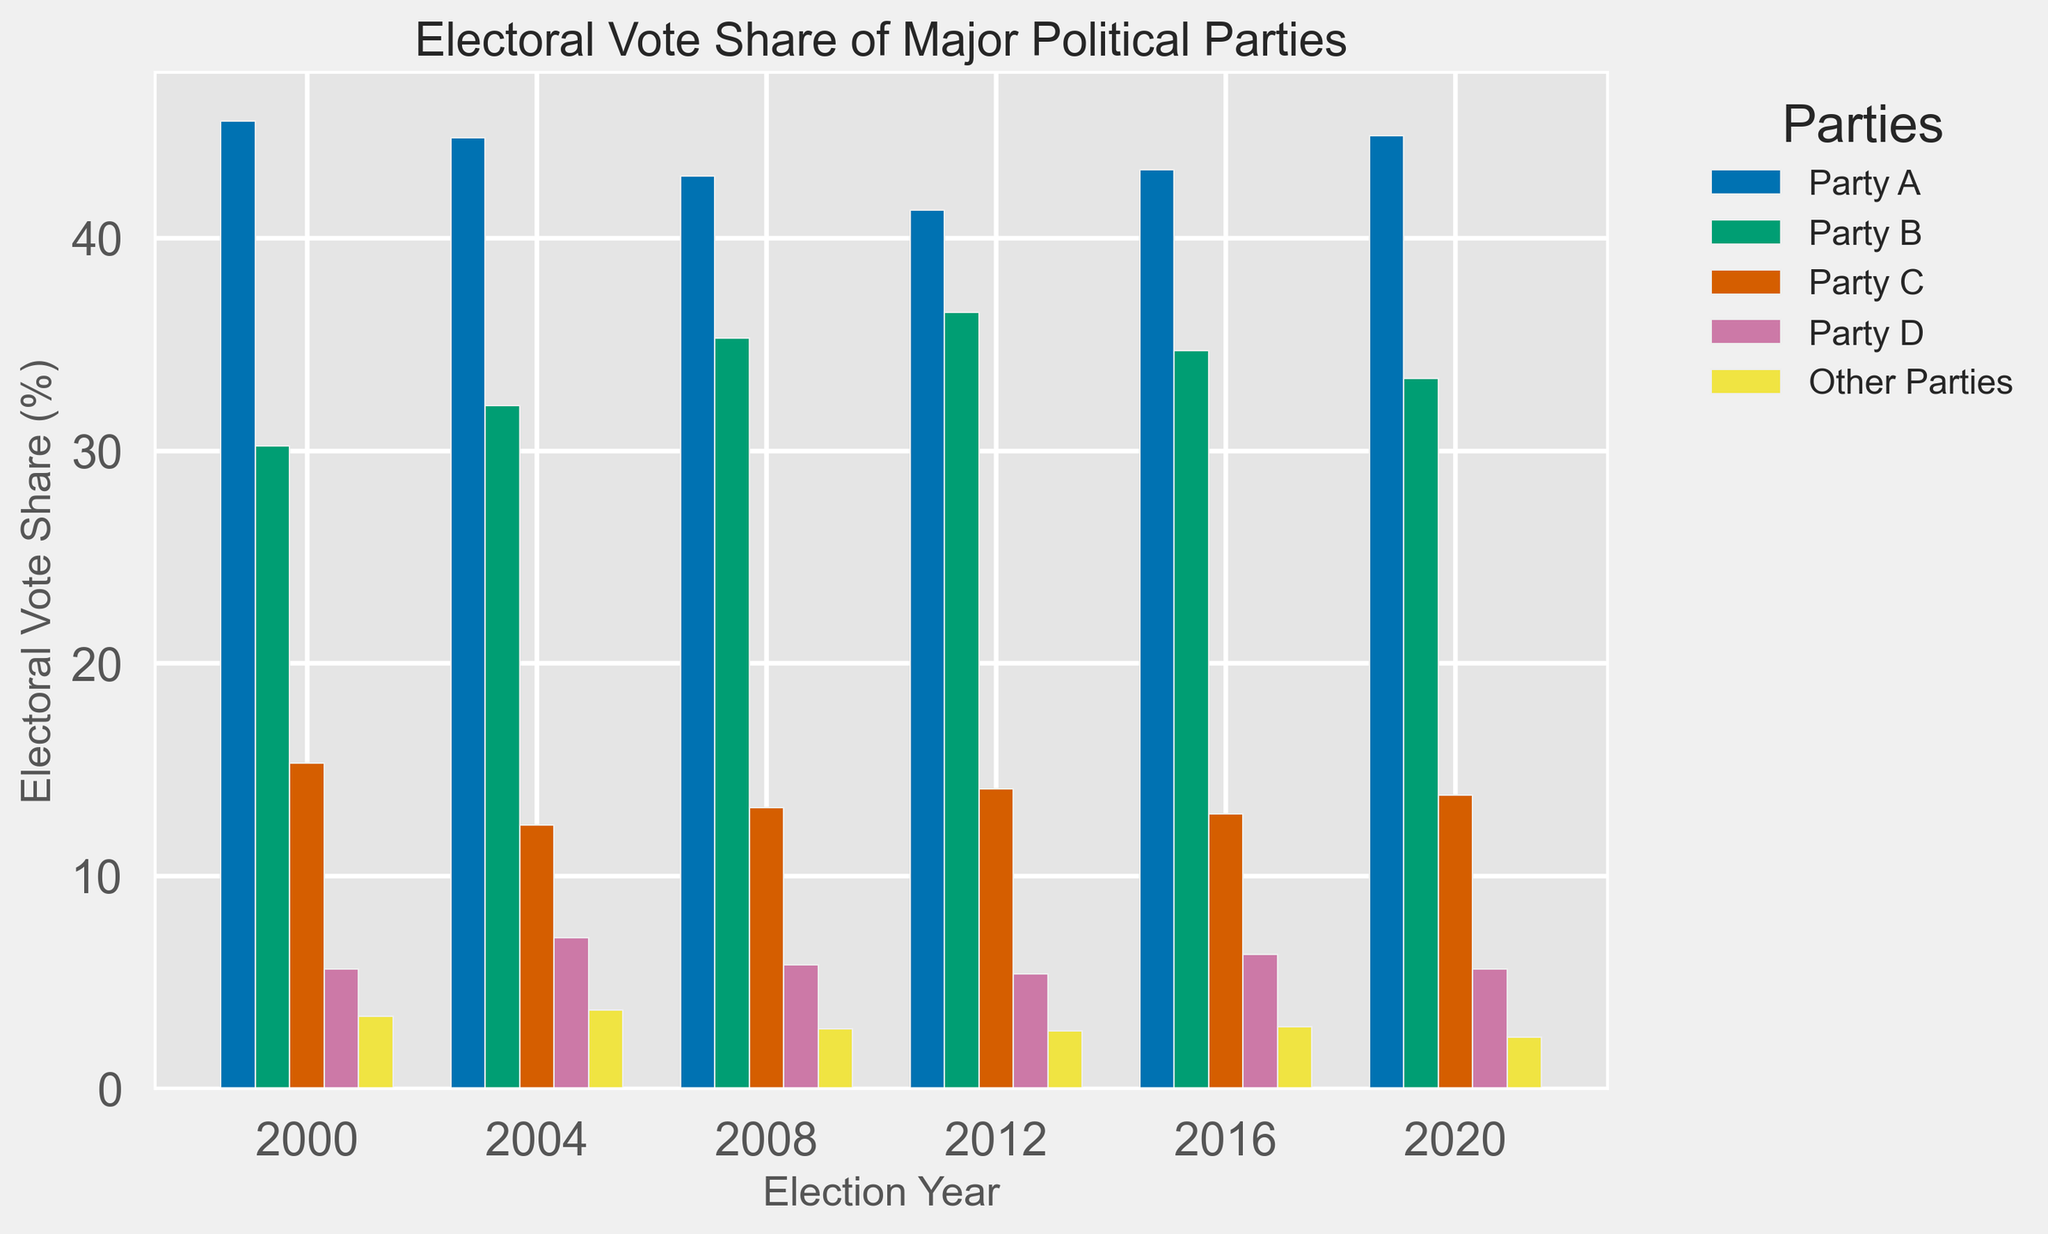What's the vote share difference between Party A in 2000 and 2020? To find the difference, subtract the vote share of Party A in 2020 from the vote share of Party A in 2000. From the chart, Party A's vote share in 2000 is 45.5% and in 2020 is 44.8%. Thus, 45.5 - 44.8 = 0.7.
Answer: 0.7 Which party experienced the largest increase in vote share between 2004 and 2008? Compare the vote share of each party in 2004 and 2008 by subtracting the 2004 value from the 2008 value. Party A: 42.9 - 44.7 = -1.8, Party B: 35.3 - 32.1 = 3.2, Party C: 13.2 - 12.4 = 0.8, Party D: 5.8 - 7.1 = -1.3, Other Parties: 2.8 - 3.7 = -0.9. Party B experienced the largest increase (3.2%).
Answer: Party B What's the trend of Party C's vote share from 2000 to 2020? Observe the vote share values of Party C over different years: 2000 (15.3), 2004 (12.4), 2008 (13.2), 2012 (14.1), 2016 (12.9), 2020 (13.8). Note the decreases from 2000 to 2004, increases from 2004 to 2012, decreases again to 2016, and an increase to 2020. Overall, Party C's vote share fluctuates without a clear increasing or decreasing trend.
Answer: Fluctuating In which year did Party B achieve its highest vote share? Observe the heights of Party B's bars and compare them across all election years. From the chart, Party B's vote shares are: 2000 (30.2%), 2004 (32.1%), 2008 (35.3%), 2012 (36.5%), 2016 (34.7%), 2020 (33.4%). The highest is in 2012 at 36.5%.
Answer: 2012 What is the average vote share of Party D across all years? To find the average, sum Party D's vote shares for all years and divide by the number of years. The sums are: 2000 (5.6), 2004 (7.1), 2008 (5.8), 2012 (5.4), 2016 (6.3), 2020 (5.6). Thus, (5.6 + 7.1 + 5.8 + 5.4 + 6.3 + 5.6) / 6 = 35.8 / 6 ≈ 5.97.
Answer: 5.97 How does the vote share of Other Parties in 2008 compare to Party D's vote share in the same year? To compare, look at the heights of the bars for Other Parties and Party D in 2008. Other Parties have a vote share of 2.8%, and Party D has a vote share of 5.8%. Thus, Other Parties' share is less than Party D's share in 2008.
Answer: Less Between which consecutive election years did Party A's vote share show the greatest decline? Calculate the difference in Party A's vote share between each pair of consecutive election years: 2000-2004 (45.5 - 44.7 = 0.8), 2004-2008 (44.7 - 42.9 = 1.8), 2008-2012 (42.9 - 41.3 = 1.6), 2012-2016 (41.3 - 43.2 = -1.9), 2016-2020 (43.2 - 44.8 = -1.6). The greatest decline occurred between 2004 and 2008 (1.8%).
Answer: 2004-2008 